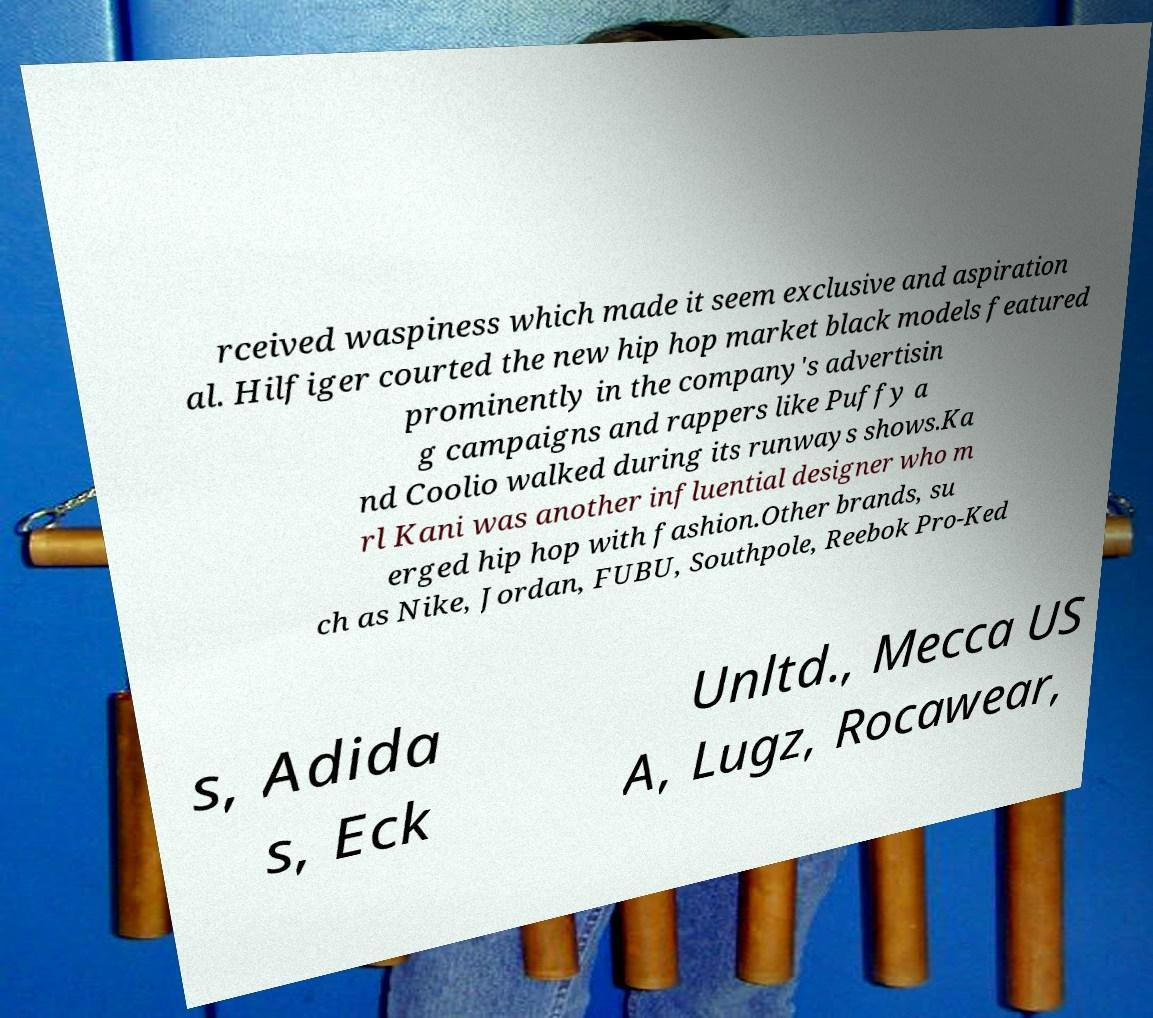There's text embedded in this image that I need extracted. Can you transcribe it verbatim? rceived waspiness which made it seem exclusive and aspiration al. Hilfiger courted the new hip hop market black models featured prominently in the company's advertisin g campaigns and rappers like Puffy a nd Coolio walked during its runways shows.Ka rl Kani was another influential designer who m erged hip hop with fashion.Other brands, su ch as Nike, Jordan, FUBU, Southpole, Reebok Pro-Ked s, Adida s, Eck Unltd., Mecca US A, Lugz, Rocawear, 